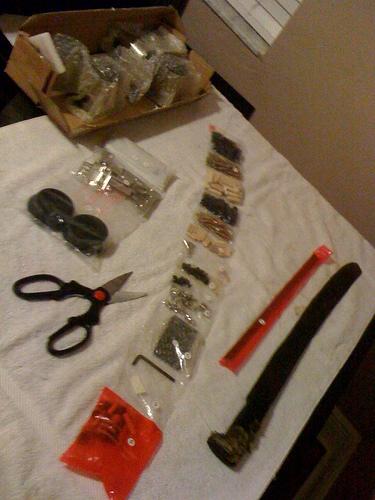What is in the plastic bag?
Concise answer only. Tools. What type of knife is in this picture?
Answer briefly. Machete. What is in the red envelopes?
Concise answer only. Nothing. Is the yarn being used?
Write a very short answer. No. What color is the scissor?
Be succinct. Black. What is the knife used for?
Answer briefly. Cutting. Is this an art project?
Answer briefly. Yes. What color is the towel?
Be succinct. White. 